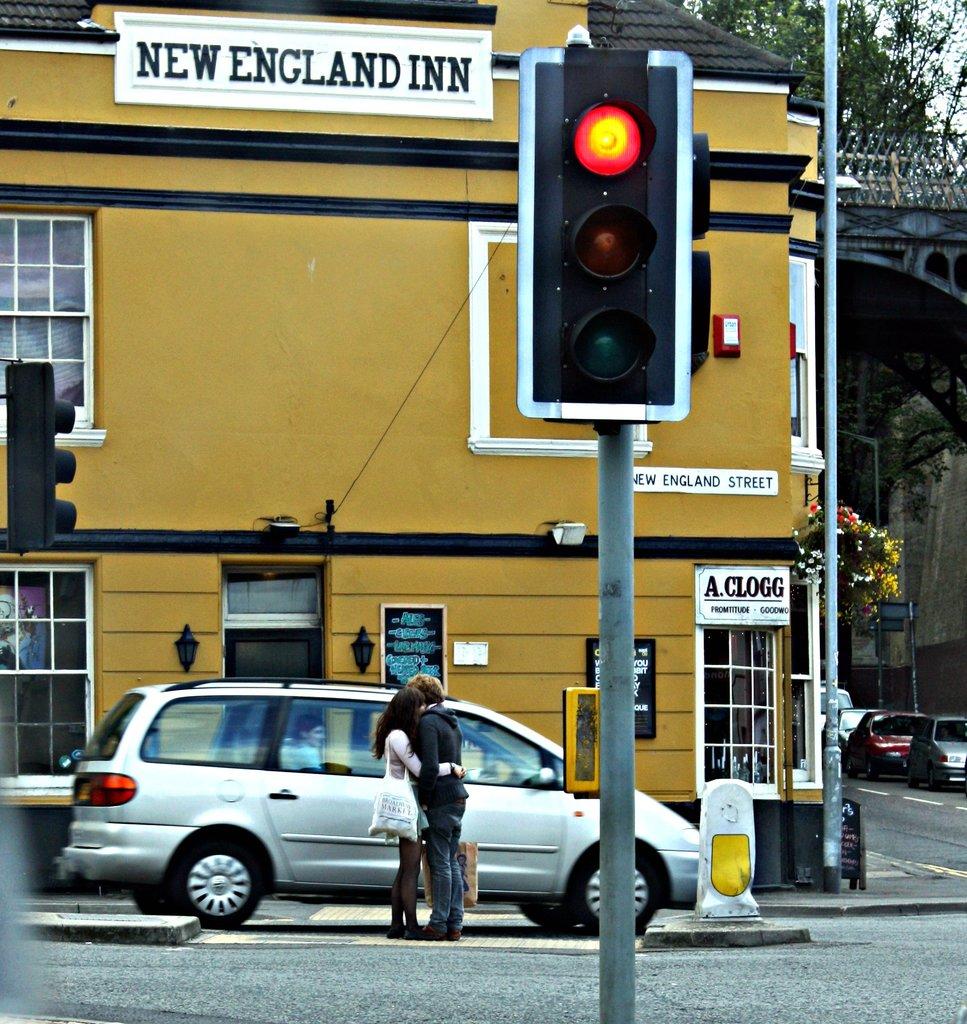What is the name of the inn?
Give a very brief answer. New england inn. This is car and van?
Offer a very short reply. Van. 